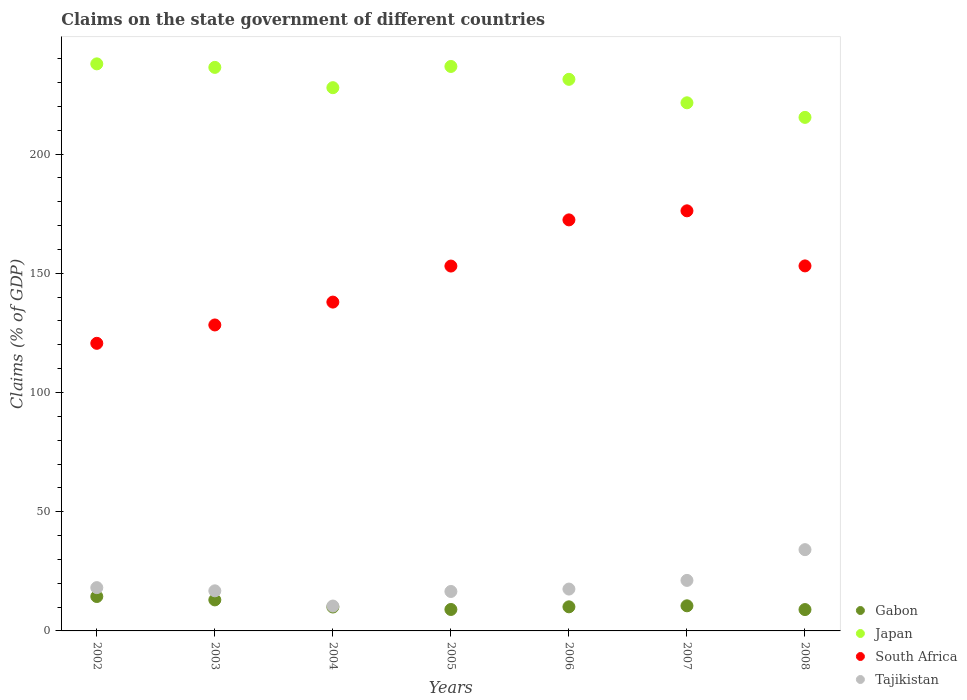How many different coloured dotlines are there?
Make the answer very short. 4. What is the percentage of GDP claimed on the state government in Japan in 2005?
Offer a very short reply. 236.77. Across all years, what is the maximum percentage of GDP claimed on the state government in Gabon?
Give a very brief answer. 14.43. Across all years, what is the minimum percentage of GDP claimed on the state government in Gabon?
Offer a terse response. 8.96. What is the total percentage of GDP claimed on the state government in Tajikistan in the graph?
Offer a terse response. 134.79. What is the difference between the percentage of GDP claimed on the state government in Tajikistan in 2003 and that in 2007?
Your response must be concise. -4.37. What is the difference between the percentage of GDP claimed on the state government in Japan in 2002 and the percentage of GDP claimed on the state government in Tajikistan in 2007?
Your answer should be very brief. 216.66. What is the average percentage of GDP claimed on the state government in Gabon per year?
Your answer should be very brief. 10.87. In the year 2008, what is the difference between the percentage of GDP claimed on the state government in Japan and percentage of GDP claimed on the state government in Gabon?
Keep it short and to the point. 206.45. In how many years, is the percentage of GDP claimed on the state government in Japan greater than 200 %?
Provide a succinct answer. 7. What is the ratio of the percentage of GDP claimed on the state government in Tajikistan in 2003 to that in 2006?
Your response must be concise. 0.96. Is the percentage of GDP claimed on the state government in Tajikistan in 2005 less than that in 2008?
Offer a terse response. Yes. Is the difference between the percentage of GDP claimed on the state government in Japan in 2004 and 2007 greater than the difference between the percentage of GDP claimed on the state government in Gabon in 2004 and 2007?
Make the answer very short. Yes. What is the difference between the highest and the second highest percentage of GDP claimed on the state government in Tajikistan?
Provide a short and direct response. 12.9. What is the difference between the highest and the lowest percentage of GDP claimed on the state government in Japan?
Keep it short and to the point. 22.45. In how many years, is the percentage of GDP claimed on the state government in Tajikistan greater than the average percentage of GDP claimed on the state government in Tajikistan taken over all years?
Offer a terse response. 2. Is the sum of the percentage of GDP claimed on the state government in Tajikistan in 2004 and 2007 greater than the maximum percentage of GDP claimed on the state government in Gabon across all years?
Your answer should be very brief. Yes. What is the difference between two consecutive major ticks on the Y-axis?
Your response must be concise. 50. Are the values on the major ticks of Y-axis written in scientific E-notation?
Your response must be concise. No. Does the graph contain grids?
Make the answer very short. No. Where does the legend appear in the graph?
Your response must be concise. Bottom right. How are the legend labels stacked?
Provide a succinct answer. Vertical. What is the title of the graph?
Make the answer very short. Claims on the state government of different countries. Does "Europe(all income levels)" appear as one of the legend labels in the graph?
Ensure brevity in your answer.  No. What is the label or title of the X-axis?
Your answer should be compact. Years. What is the label or title of the Y-axis?
Offer a very short reply. Claims (% of GDP). What is the Claims (% of GDP) in Gabon in 2002?
Provide a short and direct response. 14.43. What is the Claims (% of GDP) in Japan in 2002?
Provide a short and direct response. 237.85. What is the Claims (% of GDP) of South Africa in 2002?
Provide a short and direct response. 120.63. What is the Claims (% of GDP) in Tajikistan in 2002?
Make the answer very short. 18.16. What is the Claims (% of GDP) of Gabon in 2003?
Ensure brevity in your answer.  13.01. What is the Claims (% of GDP) of Japan in 2003?
Provide a succinct answer. 236.37. What is the Claims (% of GDP) in South Africa in 2003?
Keep it short and to the point. 128.34. What is the Claims (% of GDP) of Tajikistan in 2003?
Offer a very short reply. 16.82. What is the Claims (% of GDP) in Gabon in 2004?
Offer a terse response. 10.03. What is the Claims (% of GDP) in Japan in 2004?
Provide a short and direct response. 227.86. What is the Claims (% of GDP) of South Africa in 2004?
Your answer should be very brief. 137.93. What is the Claims (% of GDP) of Tajikistan in 2004?
Give a very brief answer. 10.44. What is the Claims (% of GDP) of Gabon in 2005?
Your answer should be compact. 9. What is the Claims (% of GDP) of Japan in 2005?
Make the answer very short. 236.77. What is the Claims (% of GDP) of South Africa in 2005?
Make the answer very short. 153.04. What is the Claims (% of GDP) of Tajikistan in 2005?
Provide a succinct answer. 16.54. What is the Claims (% of GDP) of Gabon in 2006?
Offer a terse response. 10.11. What is the Claims (% of GDP) of Japan in 2006?
Provide a succinct answer. 231.36. What is the Claims (% of GDP) of South Africa in 2006?
Keep it short and to the point. 172.41. What is the Claims (% of GDP) in Tajikistan in 2006?
Give a very brief answer. 17.56. What is the Claims (% of GDP) in Gabon in 2007?
Your response must be concise. 10.53. What is the Claims (% of GDP) of Japan in 2007?
Provide a succinct answer. 221.52. What is the Claims (% of GDP) in South Africa in 2007?
Provide a short and direct response. 176.21. What is the Claims (% of GDP) in Tajikistan in 2007?
Ensure brevity in your answer.  21.19. What is the Claims (% of GDP) in Gabon in 2008?
Offer a terse response. 8.96. What is the Claims (% of GDP) of Japan in 2008?
Provide a short and direct response. 215.41. What is the Claims (% of GDP) of South Africa in 2008?
Your answer should be compact. 153.11. What is the Claims (% of GDP) of Tajikistan in 2008?
Your answer should be compact. 34.09. Across all years, what is the maximum Claims (% of GDP) of Gabon?
Your response must be concise. 14.43. Across all years, what is the maximum Claims (% of GDP) of Japan?
Keep it short and to the point. 237.85. Across all years, what is the maximum Claims (% of GDP) of South Africa?
Offer a very short reply. 176.21. Across all years, what is the maximum Claims (% of GDP) of Tajikistan?
Your answer should be compact. 34.09. Across all years, what is the minimum Claims (% of GDP) in Gabon?
Ensure brevity in your answer.  8.96. Across all years, what is the minimum Claims (% of GDP) of Japan?
Provide a short and direct response. 215.41. Across all years, what is the minimum Claims (% of GDP) in South Africa?
Offer a very short reply. 120.63. Across all years, what is the minimum Claims (% of GDP) in Tajikistan?
Ensure brevity in your answer.  10.44. What is the total Claims (% of GDP) of Gabon in the graph?
Your answer should be compact. 76.07. What is the total Claims (% of GDP) of Japan in the graph?
Provide a short and direct response. 1607.15. What is the total Claims (% of GDP) in South Africa in the graph?
Make the answer very short. 1041.67. What is the total Claims (% of GDP) in Tajikistan in the graph?
Your answer should be compact. 134.79. What is the difference between the Claims (% of GDP) in Gabon in 2002 and that in 2003?
Offer a terse response. 1.42. What is the difference between the Claims (% of GDP) in Japan in 2002 and that in 2003?
Keep it short and to the point. 1.48. What is the difference between the Claims (% of GDP) in South Africa in 2002 and that in 2003?
Your response must be concise. -7.7. What is the difference between the Claims (% of GDP) in Tajikistan in 2002 and that in 2003?
Your answer should be very brief. 1.34. What is the difference between the Claims (% of GDP) in Gabon in 2002 and that in 2004?
Ensure brevity in your answer.  4.4. What is the difference between the Claims (% of GDP) in Japan in 2002 and that in 2004?
Give a very brief answer. 9.99. What is the difference between the Claims (% of GDP) of South Africa in 2002 and that in 2004?
Keep it short and to the point. -17.29. What is the difference between the Claims (% of GDP) in Tajikistan in 2002 and that in 2004?
Offer a very short reply. 7.72. What is the difference between the Claims (% of GDP) of Gabon in 2002 and that in 2005?
Ensure brevity in your answer.  5.44. What is the difference between the Claims (% of GDP) of Japan in 2002 and that in 2005?
Give a very brief answer. 1.09. What is the difference between the Claims (% of GDP) of South Africa in 2002 and that in 2005?
Ensure brevity in your answer.  -32.41. What is the difference between the Claims (% of GDP) in Tajikistan in 2002 and that in 2005?
Your answer should be very brief. 1.62. What is the difference between the Claims (% of GDP) of Gabon in 2002 and that in 2006?
Your response must be concise. 4.33. What is the difference between the Claims (% of GDP) in Japan in 2002 and that in 2006?
Offer a very short reply. 6.49. What is the difference between the Claims (% of GDP) in South Africa in 2002 and that in 2006?
Offer a very short reply. -51.77. What is the difference between the Claims (% of GDP) of Tajikistan in 2002 and that in 2006?
Provide a short and direct response. 0.6. What is the difference between the Claims (% of GDP) in Gabon in 2002 and that in 2007?
Give a very brief answer. 3.9. What is the difference between the Claims (% of GDP) in Japan in 2002 and that in 2007?
Keep it short and to the point. 16.33. What is the difference between the Claims (% of GDP) of South Africa in 2002 and that in 2007?
Ensure brevity in your answer.  -55.57. What is the difference between the Claims (% of GDP) of Tajikistan in 2002 and that in 2007?
Provide a succinct answer. -3.03. What is the difference between the Claims (% of GDP) in Gabon in 2002 and that in 2008?
Your answer should be compact. 5.48. What is the difference between the Claims (% of GDP) in Japan in 2002 and that in 2008?
Your answer should be compact. 22.45. What is the difference between the Claims (% of GDP) of South Africa in 2002 and that in 2008?
Provide a succinct answer. -32.47. What is the difference between the Claims (% of GDP) of Tajikistan in 2002 and that in 2008?
Make the answer very short. -15.93. What is the difference between the Claims (% of GDP) of Gabon in 2003 and that in 2004?
Provide a succinct answer. 2.98. What is the difference between the Claims (% of GDP) of Japan in 2003 and that in 2004?
Your answer should be very brief. 8.51. What is the difference between the Claims (% of GDP) in South Africa in 2003 and that in 2004?
Keep it short and to the point. -9.59. What is the difference between the Claims (% of GDP) in Tajikistan in 2003 and that in 2004?
Your answer should be very brief. 6.38. What is the difference between the Claims (% of GDP) in Gabon in 2003 and that in 2005?
Provide a short and direct response. 4.01. What is the difference between the Claims (% of GDP) of Japan in 2003 and that in 2005?
Ensure brevity in your answer.  -0.39. What is the difference between the Claims (% of GDP) in South Africa in 2003 and that in 2005?
Offer a very short reply. -24.7. What is the difference between the Claims (% of GDP) in Tajikistan in 2003 and that in 2005?
Offer a terse response. 0.27. What is the difference between the Claims (% of GDP) in Gabon in 2003 and that in 2006?
Keep it short and to the point. 2.9. What is the difference between the Claims (% of GDP) in Japan in 2003 and that in 2006?
Keep it short and to the point. 5.01. What is the difference between the Claims (% of GDP) in South Africa in 2003 and that in 2006?
Provide a short and direct response. -44.07. What is the difference between the Claims (% of GDP) in Tajikistan in 2003 and that in 2006?
Keep it short and to the point. -0.74. What is the difference between the Claims (% of GDP) in Gabon in 2003 and that in 2007?
Offer a very short reply. 2.48. What is the difference between the Claims (% of GDP) of Japan in 2003 and that in 2007?
Your answer should be very brief. 14.85. What is the difference between the Claims (% of GDP) of South Africa in 2003 and that in 2007?
Offer a very short reply. -47.87. What is the difference between the Claims (% of GDP) of Tajikistan in 2003 and that in 2007?
Your response must be concise. -4.37. What is the difference between the Claims (% of GDP) in Gabon in 2003 and that in 2008?
Ensure brevity in your answer.  4.05. What is the difference between the Claims (% of GDP) of Japan in 2003 and that in 2008?
Make the answer very short. 20.97. What is the difference between the Claims (% of GDP) of South Africa in 2003 and that in 2008?
Ensure brevity in your answer.  -24.77. What is the difference between the Claims (% of GDP) in Tajikistan in 2003 and that in 2008?
Give a very brief answer. -17.27. What is the difference between the Claims (% of GDP) of Gabon in 2004 and that in 2005?
Provide a short and direct response. 1.04. What is the difference between the Claims (% of GDP) in Japan in 2004 and that in 2005?
Your answer should be very brief. -8.9. What is the difference between the Claims (% of GDP) of South Africa in 2004 and that in 2005?
Offer a very short reply. -15.12. What is the difference between the Claims (% of GDP) of Tajikistan in 2004 and that in 2005?
Your response must be concise. -6.11. What is the difference between the Claims (% of GDP) of Gabon in 2004 and that in 2006?
Provide a short and direct response. -0.07. What is the difference between the Claims (% of GDP) in Japan in 2004 and that in 2006?
Provide a succinct answer. -3.5. What is the difference between the Claims (% of GDP) in South Africa in 2004 and that in 2006?
Provide a short and direct response. -34.48. What is the difference between the Claims (% of GDP) of Tajikistan in 2004 and that in 2006?
Offer a very short reply. -7.12. What is the difference between the Claims (% of GDP) of Gabon in 2004 and that in 2007?
Your answer should be very brief. -0.5. What is the difference between the Claims (% of GDP) in Japan in 2004 and that in 2007?
Give a very brief answer. 6.34. What is the difference between the Claims (% of GDP) in South Africa in 2004 and that in 2007?
Your response must be concise. -38.28. What is the difference between the Claims (% of GDP) in Tajikistan in 2004 and that in 2007?
Offer a terse response. -10.75. What is the difference between the Claims (% of GDP) in Gabon in 2004 and that in 2008?
Give a very brief answer. 1.08. What is the difference between the Claims (% of GDP) in Japan in 2004 and that in 2008?
Make the answer very short. 12.46. What is the difference between the Claims (% of GDP) of South Africa in 2004 and that in 2008?
Offer a very short reply. -15.18. What is the difference between the Claims (% of GDP) of Tajikistan in 2004 and that in 2008?
Your answer should be compact. -23.65. What is the difference between the Claims (% of GDP) of Gabon in 2005 and that in 2006?
Your answer should be compact. -1.11. What is the difference between the Claims (% of GDP) in Japan in 2005 and that in 2006?
Ensure brevity in your answer.  5.4. What is the difference between the Claims (% of GDP) in South Africa in 2005 and that in 2006?
Ensure brevity in your answer.  -19.37. What is the difference between the Claims (% of GDP) in Tajikistan in 2005 and that in 2006?
Offer a very short reply. -1.01. What is the difference between the Claims (% of GDP) in Gabon in 2005 and that in 2007?
Your answer should be compact. -1.54. What is the difference between the Claims (% of GDP) of Japan in 2005 and that in 2007?
Your response must be concise. 15.24. What is the difference between the Claims (% of GDP) of South Africa in 2005 and that in 2007?
Offer a terse response. -23.17. What is the difference between the Claims (% of GDP) in Tajikistan in 2005 and that in 2007?
Your answer should be very brief. -4.65. What is the difference between the Claims (% of GDP) in Gabon in 2005 and that in 2008?
Provide a succinct answer. 0.04. What is the difference between the Claims (% of GDP) in Japan in 2005 and that in 2008?
Keep it short and to the point. 21.36. What is the difference between the Claims (% of GDP) in South Africa in 2005 and that in 2008?
Give a very brief answer. -0.06. What is the difference between the Claims (% of GDP) in Tajikistan in 2005 and that in 2008?
Provide a short and direct response. -17.55. What is the difference between the Claims (% of GDP) of Gabon in 2006 and that in 2007?
Give a very brief answer. -0.43. What is the difference between the Claims (% of GDP) in Japan in 2006 and that in 2007?
Your response must be concise. 9.84. What is the difference between the Claims (% of GDP) of South Africa in 2006 and that in 2007?
Ensure brevity in your answer.  -3.8. What is the difference between the Claims (% of GDP) in Tajikistan in 2006 and that in 2007?
Ensure brevity in your answer.  -3.63. What is the difference between the Claims (% of GDP) in Gabon in 2006 and that in 2008?
Your answer should be compact. 1.15. What is the difference between the Claims (% of GDP) in Japan in 2006 and that in 2008?
Provide a short and direct response. 15.96. What is the difference between the Claims (% of GDP) in South Africa in 2006 and that in 2008?
Provide a short and direct response. 19.3. What is the difference between the Claims (% of GDP) of Tajikistan in 2006 and that in 2008?
Ensure brevity in your answer.  -16.53. What is the difference between the Claims (% of GDP) in Gabon in 2007 and that in 2008?
Offer a terse response. 1.58. What is the difference between the Claims (% of GDP) of Japan in 2007 and that in 2008?
Your answer should be compact. 6.12. What is the difference between the Claims (% of GDP) in South Africa in 2007 and that in 2008?
Your answer should be very brief. 23.1. What is the difference between the Claims (% of GDP) in Tajikistan in 2007 and that in 2008?
Offer a terse response. -12.9. What is the difference between the Claims (% of GDP) of Gabon in 2002 and the Claims (% of GDP) of Japan in 2003?
Ensure brevity in your answer.  -221.94. What is the difference between the Claims (% of GDP) in Gabon in 2002 and the Claims (% of GDP) in South Africa in 2003?
Ensure brevity in your answer.  -113.9. What is the difference between the Claims (% of GDP) of Gabon in 2002 and the Claims (% of GDP) of Tajikistan in 2003?
Ensure brevity in your answer.  -2.38. What is the difference between the Claims (% of GDP) of Japan in 2002 and the Claims (% of GDP) of South Africa in 2003?
Provide a short and direct response. 109.52. What is the difference between the Claims (% of GDP) in Japan in 2002 and the Claims (% of GDP) in Tajikistan in 2003?
Make the answer very short. 221.04. What is the difference between the Claims (% of GDP) of South Africa in 2002 and the Claims (% of GDP) of Tajikistan in 2003?
Offer a terse response. 103.82. What is the difference between the Claims (% of GDP) of Gabon in 2002 and the Claims (% of GDP) of Japan in 2004?
Your answer should be compact. -213.43. What is the difference between the Claims (% of GDP) of Gabon in 2002 and the Claims (% of GDP) of South Africa in 2004?
Offer a very short reply. -123.49. What is the difference between the Claims (% of GDP) of Gabon in 2002 and the Claims (% of GDP) of Tajikistan in 2004?
Offer a very short reply. 4. What is the difference between the Claims (% of GDP) of Japan in 2002 and the Claims (% of GDP) of South Africa in 2004?
Give a very brief answer. 99.93. What is the difference between the Claims (% of GDP) of Japan in 2002 and the Claims (% of GDP) of Tajikistan in 2004?
Your answer should be very brief. 227.42. What is the difference between the Claims (% of GDP) in South Africa in 2002 and the Claims (% of GDP) in Tajikistan in 2004?
Your answer should be very brief. 110.2. What is the difference between the Claims (% of GDP) in Gabon in 2002 and the Claims (% of GDP) in Japan in 2005?
Give a very brief answer. -222.33. What is the difference between the Claims (% of GDP) of Gabon in 2002 and the Claims (% of GDP) of South Africa in 2005?
Ensure brevity in your answer.  -138.61. What is the difference between the Claims (% of GDP) of Gabon in 2002 and the Claims (% of GDP) of Tajikistan in 2005?
Keep it short and to the point. -2.11. What is the difference between the Claims (% of GDP) of Japan in 2002 and the Claims (% of GDP) of South Africa in 2005?
Offer a very short reply. 84.81. What is the difference between the Claims (% of GDP) of Japan in 2002 and the Claims (% of GDP) of Tajikistan in 2005?
Offer a very short reply. 221.31. What is the difference between the Claims (% of GDP) in South Africa in 2002 and the Claims (% of GDP) in Tajikistan in 2005?
Give a very brief answer. 104.09. What is the difference between the Claims (% of GDP) in Gabon in 2002 and the Claims (% of GDP) in Japan in 2006?
Make the answer very short. -216.93. What is the difference between the Claims (% of GDP) of Gabon in 2002 and the Claims (% of GDP) of South Africa in 2006?
Your response must be concise. -157.97. What is the difference between the Claims (% of GDP) in Gabon in 2002 and the Claims (% of GDP) in Tajikistan in 2006?
Provide a succinct answer. -3.12. What is the difference between the Claims (% of GDP) in Japan in 2002 and the Claims (% of GDP) in South Africa in 2006?
Give a very brief answer. 65.45. What is the difference between the Claims (% of GDP) in Japan in 2002 and the Claims (% of GDP) in Tajikistan in 2006?
Give a very brief answer. 220.3. What is the difference between the Claims (% of GDP) in South Africa in 2002 and the Claims (% of GDP) in Tajikistan in 2006?
Make the answer very short. 103.08. What is the difference between the Claims (% of GDP) in Gabon in 2002 and the Claims (% of GDP) in Japan in 2007?
Give a very brief answer. -207.09. What is the difference between the Claims (% of GDP) in Gabon in 2002 and the Claims (% of GDP) in South Africa in 2007?
Your answer should be compact. -161.77. What is the difference between the Claims (% of GDP) of Gabon in 2002 and the Claims (% of GDP) of Tajikistan in 2007?
Offer a very short reply. -6.76. What is the difference between the Claims (% of GDP) in Japan in 2002 and the Claims (% of GDP) in South Africa in 2007?
Your response must be concise. 61.65. What is the difference between the Claims (% of GDP) in Japan in 2002 and the Claims (% of GDP) in Tajikistan in 2007?
Make the answer very short. 216.66. What is the difference between the Claims (% of GDP) in South Africa in 2002 and the Claims (% of GDP) in Tajikistan in 2007?
Offer a very short reply. 99.44. What is the difference between the Claims (% of GDP) in Gabon in 2002 and the Claims (% of GDP) in Japan in 2008?
Offer a terse response. -200.97. What is the difference between the Claims (% of GDP) in Gabon in 2002 and the Claims (% of GDP) in South Africa in 2008?
Give a very brief answer. -138.67. What is the difference between the Claims (% of GDP) in Gabon in 2002 and the Claims (% of GDP) in Tajikistan in 2008?
Offer a terse response. -19.66. What is the difference between the Claims (% of GDP) in Japan in 2002 and the Claims (% of GDP) in South Africa in 2008?
Make the answer very short. 84.75. What is the difference between the Claims (% of GDP) in Japan in 2002 and the Claims (% of GDP) in Tajikistan in 2008?
Offer a terse response. 203.76. What is the difference between the Claims (% of GDP) in South Africa in 2002 and the Claims (% of GDP) in Tajikistan in 2008?
Your response must be concise. 86.54. What is the difference between the Claims (% of GDP) of Gabon in 2003 and the Claims (% of GDP) of Japan in 2004?
Provide a short and direct response. -214.85. What is the difference between the Claims (% of GDP) in Gabon in 2003 and the Claims (% of GDP) in South Africa in 2004?
Keep it short and to the point. -124.92. What is the difference between the Claims (% of GDP) of Gabon in 2003 and the Claims (% of GDP) of Tajikistan in 2004?
Your answer should be compact. 2.58. What is the difference between the Claims (% of GDP) of Japan in 2003 and the Claims (% of GDP) of South Africa in 2004?
Offer a terse response. 98.45. What is the difference between the Claims (% of GDP) in Japan in 2003 and the Claims (% of GDP) in Tajikistan in 2004?
Offer a terse response. 225.94. What is the difference between the Claims (% of GDP) in South Africa in 2003 and the Claims (% of GDP) in Tajikistan in 2004?
Give a very brief answer. 117.9. What is the difference between the Claims (% of GDP) of Gabon in 2003 and the Claims (% of GDP) of Japan in 2005?
Provide a succinct answer. -223.76. What is the difference between the Claims (% of GDP) of Gabon in 2003 and the Claims (% of GDP) of South Africa in 2005?
Offer a very short reply. -140.03. What is the difference between the Claims (% of GDP) in Gabon in 2003 and the Claims (% of GDP) in Tajikistan in 2005?
Provide a short and direct response. -3.53. What is the difference between the Claims (% of GDP) of Japan in 2003 and the Claims (% of GDP) of South Africa in 2005?
Give a very brief answer. 83.33. What is the difference between the Claims (% of GDP) of Japan in 2003 and the Claims (% of GDP) of Tajikistan in 2005?
Offer a very short reply. 219.83. What is the difference between the Claims (% of GDP) of South Africa in 2003 and the Claims (% of GDP) of Tajikistan in 2005?
Provide a succinct answer. 111.79. What is the difference between the Claims (% of GDP) of Gabon in 2003 and the Claims (% of GDP) of Japan in 2006?
Provide a short and direct response. -218.35. What is the difference between the Claims (% of GDP) in Gabon in 2003 and the Claims (% of GDP) in South Africa in 2006?
Make the answer very short. -159.4. What is the difference between the Claims (% of GDP) of Gabon in 2003 and the Claims (% of GDP) of Tajikistan in 2006?
Offer a terse response. -4.54. What is the difference between the Claims (% of GDP) of Japan in 2003 and the Claims (% of GDP) of South Africa in 2006?
Provide a short and direct response. 63.97. What is the difference between the Claims (% of GDP) of Japan in 2003 and the Claims (% of GDP) of Tajikistan in 2006?
Your answer should be compact. 218.82. What is the difference between the Claims (% of GDP) of South Africa in 2003 and the Claims (% of GDP) of Tajikistan in 2006?
Give a very brief answer. 110.78. What is the difference between the Claims (% of GDP) in Gabon in 2003 and the Claims (% of GDP) in Japan in 2007?
Your answer should be compact. -208.51. What is the difference between the Claims (% of GDP) of Gabon in 2003 and the Claims (% of GDP) of South Africa in 2007?
Ensure brevity in your answer.  -163.2. What is the difference between the Claims (% of GDP) of Gabon in 2003 and the Claims (% of GDP) of Tajikistan in 2007?
Offer a terse response. -8.18. What is the difference between the Claims (% of GDP) of Japan in 2003 and the Claims (% of GDP) of South Africa in 2007?
Your response must be concise. 60.17. What is the difference between the Claims (% of GDP) in Japan in 2003 and the Claims (% of GDP) in Tajikistan in 2007?
Provide a succinct answer. 215.18. What is the difference between the Claims (% of GDP) in South Africa in 2003 and the Claims (% of GDP) in Tajikistan in 2007?
Ensure brevity in your answer.  107.15. What is the difference between the Claims (% of GDP) in Gabon in 2003 and the Claims (% of GDP) in Japan in 2008?
Provide a succinct answer. -202.4. What is the difference between the Claims (% of GDP) in Gabon in 2003 and the Claims (% of GDP) in South Africa in 2008?
Provide a short and direct response. -140.1. What is the difference between the Claims (% of GDP) of Gabon in 2003 and the Claims (% of GDP) of Tajikistan in 2008?
Your response must be concise. -21.08. What is the difference between the Claims (% of GDP) in Japan in 2003 and the Claims (% of GDP) in South Africa in 2008?
Make the answer very short. 83.27. What is the difference between the Claims (% of GDP) of Japan in 2003 and the Claims (% of GDP) of Tajikistan in 2008?
Your answer should be compact. 202.28. What is the difference between the Claims (% of GDP) of South Africa in 2003 and the Claims (% of GDP) of Tajikistan in 2008?
Make the answer very short. 94.25. What is the difference between the Claims (% of GDP) in Gabon in 2004 and the Claims (% of GDP) in Japan in 2005?
Provide a succinct answer. -226.73. What is the difference between the Claims (% of GDP) of Gabon in 2004 and the Claims (% of GDP) of South Africa in 2005?
Provide a short and direct response. -143.01. What is the difference between the Claims (% of GDP) of Gabon in 2004 and the Claims (% of GDP) of Tajikistan in 2005?
Ensure brevity in your answer.  -6.51. What is the difference between the Claims (% of GDP) in Japan in 2004 and the Claims (% of GDP) in South Africa in 2005?
Ensure brevity in your answer.  74.82. What is the difference between the Claims (% of GDP) of Japan in 2004 and the Claims (% of GDP) of Tajikistan in 2005?
Make the answer very short. 211.32. What is the difference between the Claims (% of GDP) in South Africa in 2004 and the Claims (% of GDP) in Tajikistan in 2005?
Offer a very short reply. 121.38. What is the difference between the Claims (% of GDP) in Gabon in 2004 and the Claims (% of GDP) in Japan in 2006?
Offer a terse response. -221.33. What is the difference between the Claims (% of GDP) in Gabon in 2004 and the Claims (% of GDP) in South Africa in 2006?
Your answer should be compact. -162.38. What is the difference between the Claims (% of GDP) in Gabon in 2004 and the Claims (% of GDP) in Tajikistan in 2006?
Provide a succinct answer. -7.52. What is the difference between the Claims (% of GDP) in Japan in 2004 and the Claims (% of GDP) in South Africa in 2006?
Provide a short and direct response. 55.45. What is the difference between the Claims (% of GDP) in Japan in 2004 and the Claims (% of GDP) in Tajikistan in 2006?
Provide a succinct answer. 210.31. What is the difference between the Claims (% of GDP) in South Africa in 2004 and the Claims (% of GDP) in Tajikistan in 2006?
Offer a terse response. 120.37. What is the difference between the Claims (% of GDP) of Gabon in 2004 and the Claims (% of GDP) of Japan in 2007?
Offer a very short reply. -211.49. What is the difference between the Claims (% of GDP) of Gabon in 2004 and the Claims (% of GDP) of South Africa in 2007?
Make the answer very short. -166.18. What is the difference between the Claims (% of GDP) of Gabon in 2004 and the Claims (% of GDP) of Tajikistan in 2007?
Make the answer very short. -11.16. What is the difference between the Claims (% of GDP) of Japan in 2004 and the Claims (% of GDP) of South Africa in 2007?
Your answer should be compact. 51.65. What is the difference between the Claims (% of GDP) in Japan in 2004 and the Claims (% of GDP) in Tajikistan in 2007?
Provide a succinct answer. 206.67. What is the difference between the Claims (% of GDP) of South Africa in 2004 and the Claims (% of GDP) of Tajikistan in 2007?
Ensure brevity in your answer.  116.74. What is the difference between the Claims (% of GDP) of Gabon in 2004 and the Claims (% of GDP) of Japan in 2008?
Provide a succinct answer. -205.37. What is the difference between the Claims (% of GDP) in Gabon in 2004 and the Claims (% of GDP) in South Africa in 2008?
Your answer should be very brief. -143.07. What is the difference between the Claims (% of GDP) in Gabon in 2004 and the Claims (% of GDP) in Tajikistan in 2008?
Offer a very short reply. -24.06. What is the difference between the Claims (% of GDP) of Japan in 2004 and the Claims (% of GDP) of South Africa in 2008?
Give a very brief answer. 74.76. What is the difference between the Claims (% of GDP) of Japan in 2004 and the Claims (% of GDP) of Tajikistan in 2008?
Give a very brief answer. 193.77. What is the difference between the Claims (% of GDP) of South Africa in 2004 and the Claims (% of GDP) of Tajikistan in 2008?
Offer a terse response. 103.84. What is the difference between the Claims (% of GDP) in Gabon in 2005 and the Claims (% of GDP) in Japan in 2006?
Your answer should be compact. -222.37. What is the difference between the Claims (% of GDP) of Gabon in 2005 and the Claims (% of GDP) of South Africa in 2006?
Make the answer very short. -163.41. What is the difference between the Claims (% of GDP) in Gabon in 2005 and the Claims (% of GDP) in Tajikistan in 2006?
Offer a terse response. -8.56. What is the difference between the Claims (% of GDP) in Japan in 2005 and the Claims (% of GDP) in South Africa in 2006?
Your answer should be very brief. 64.36. What is the difference between the Claims (% of GDP) in Japan in 2005 and the Claims (% of GDP) in Tajikistan in 2006?
Ensure brevity in your answer.  219.21. What is the difference between the Claims (% of GDP) in South Africa in 2005 and the Claims (% of GDP) in Tajikistan in 2006?
Make the answer very short. 135.49. What is the difference between the Claims (% of GDP) of Gabon in 2005 and the Claims (% of GDP) of Japan in 2007?
Make the answer very short. -212.53. What is the difference between the Claims (% of GDP) of Gabon in 2005 and the Claims (% of GDP) of South Africa in 2007?
Provide a succinct answer. -167.21. What is the difference between the Claims (% of GDP) of Gabon in 2005 and the Claims (% of GDP) of Tajikistan in 2007?
Offer a very short reply. -12.19. What is the difference between the Claims (% of GDP) of Japan in 2005 and the Claims (% of GDP) of South Africa in 2007?
Make the answer very short. 60.56. What is the difference between the Claims (% of GDP) of Japan in 2005 and the Claims (% of GDP) of Tajikistan in 2007?
Give a very brief answer. 215.58. What is the difference between the Claims (% of GDP) in South Africa in 2005 and the Claims (% of GDP) in Tajikistan in 2007?
Provide a succinct answer. 131.85. What is the difference between the Claims (% of GDP) in Gabon in 2005 and the Claims (% of GDP) in Japan in 2008?
Give a very brief answer. -206.41. What is the difference between the Claims (% of GDP) in Gabon in 2005 and the Claims (% of GDP) in South Africa in 2008?
Offer a terse response. -144.11. What is the difference between the Claims (% of GDP) of Gabon in 2005 and the Claims (% of GDP) of Tajikistan in 2008?
Give a very brief answer. -25.09. What is the difference between the Claims (% of GDP) of Japan in 2005 and the Claims (% of GDP) of South Africa in 2008?
Your answer should be very brief. 83.66. What is the difference between the Claims (% of GDP) in Japan in 2005 and the Claims (% of GDP) in Tajikistan in 2008?
Ensure brevity in your answer.  202.68. What is the difference between the Claims (% of GDP) in South Africa in 2005 and the Claims (% of GDP) in Tajikistan in 2008?
Provide a succinct answer. 118.95. What is the difference between the Claims (% of GDP) in Gabon in 2006 and the Claims (% of GDP) in Japan in 2007?
Provide a short and direct response. -211.42. What is the difference between the Claims (% of GDP) in Gabon in 2006 and the Claims (% of GDP) in South Africa in 2007?
Offer a very short reply. -166.1. What is the difference between the Claims (% of GDP) of Gabon in 2006 and the Claims (% of GDP) of Tajikistan in 2007?
Provide a short and direct response. -11.08. What is the difference between the Claims (% of GDP) in Japan in 2006 and the Claims (% of GDP) in South Africa in 2007?
Provide a short and direct response. 55.16. What is the difference between the Claims (% of GDP) of Japan in 2006 and the Claims (% of GDP) of Tajikistan in 2007?
Keep it short and to the point. 210.17. What is the difference between the Claims (% of GDP) of South Africa in 2006 and the Claims (% of GDP) of Tajikistan in 2007?
Make the answer very short. 151.22. What is the difference between the Claims (% of GDP) in Gabon in 2006 and the Claims (% of GDP) in Japan in 2008?
Provide a short and direct response. -205.3. What is the difference between the Claims (% of GDP) of Gabon in 2006 and the Claims (% of GDP) of South Africa in 2008?
Your response must be concise. -143. What is the difference between the Claims (% of GDP) of Gabon in 2006 and the Claims (% of GDP) of Tajikistan in 2008?
Ensure brevity in your answer.  -23.98. What is the difference between the Claims (% of GDP) in Japan in 2006 and the Claims (% of GDP) in South Africa in 2008?
Provide a succinct answer. 78.26. What is the difference between the Claims (% of GDP) of Japan in 2006 and the Claims (% of GDP) of Tajikistan in 2008?
Give a very brief answer. 197.27. What is the difference between the Claims (% of GDP) in South Africa in 2006 and the Claims (% of GDP) in Tajikistan in 2008?
Make the answer very short. 138.32. What is the difference between the Claims (% of GDP) of Gabon in 2007 and the Claims (% of GDP) of Japan in 2008?
Your answer should be compact. -204.87. What is the difference between the Claims (% of GDP) of Gabon in 2007 and the Claims (% of GDP) of South Africa in 2008?
Ensure brevity in your answer.  -142.57. What is the difference between the Claims (% of GDP) in Gabon in 2007 and the Claims (% of GDP) in Tajikistan in 2008?
Provide a succinct answer. -23.56. What is the difference between the Claims (% of GDP) of Japan in 2007 and the Claims (% of GDP) of South Africa in 2008?
Ensure brevity in your answer.  68.42. What is the difference between the Claims (% of GDP) of Japan in 2007 and the Claims (% of GDP) of Tajikistan in 2008?
Keep it short and to the point. 187.43. What is the difference between the Claims (% of GDP) of South Africa in 2007 and the Claims (% of GDP) of Tajikistan in 2008?
Give a very brief answer. 142.12. What is the average Claims (% of GDP) of Gabon per year?
Provide a short and direct response. 10.87. What is the average Claims (% of GDP) in Japan per year?
Your answer should be very brief. 229.59. What is the average Claims (% of GDP) of South Africa per year?
Your answer should be very brief. 148.81. What is the average Claims (% of GDP) in Tajikistan per year?
Ensure brevity in your answer.  19.26. In the year 2002, what is the difference between the Claims (% of GDP) in Gabon and Claims (% of GDP) in Japan?
Provide a succinct answer. -223.42. In the year 2002, what is the difference between the Claims (% of GDP) of Gabon and Claims (% of GDP) of South Africa?
Your answer should be very brief. -106.2. In the year 2002, what is the difference between the Claims (% of GDP) in Gabon and Claims (% of GDP) in Tajikistan?
Offer a very short reply. -3.73. In the year 2002, what is the difference between the Claims (% of GDP) in Japan and Claims (% of GDP) in South Africa?
Provide a succinct answer. 117.22. In the year 2002, what is the difference between the Claims (% of GDP) of Japan and Claims (% of GDP) of Tajikistan?
Make the answer very short. 219.69. In the year 2002, what is the difference between the Claims (% of GDP) in South Africa and Claims (% of GDP) in Tajikistan?
Your response must be concise. 102.47. In the year 2003, what is the difference between the Claims (% of GDP) in Gabon and Claims (% of GDP) in Japan?
Make the answer very short. -223.36. In the year 2003, what is the difference between the Claims (% of GDP) of Gabon and Claims (% of GDP) of South Africa?
Make the answer very short. -115.33. In the year 2003, what is the difference between the Claims (% of GDP) of Gabon and Claims (% of GDP) of Tajikistan?
Provide a succinct answer. -3.81. In the year 2003, what is the difference between the Claims (% of GDP) of Japan and Claims (% of GDP) of South Africa?
Provide a succinct answer. 108.04. In the year 2003, what is the difference between the Claims (% of GDP) in Japan and Claims (% of GDP) in Tajikistan?
Offer a terse response. 219.56. In the year 2003, what is the difference between the Claims (% of GDP) in South Africa and Claims (% of GDP) in Tajikistan?
Provide a succinct answer. 111.52. In the year 2004, what is the difference between the Claims (% of GDP) of Gabon and Claims (% of GDP) of Japan?
Keep it short and to the point. -217.83. In the year 2004, what is the difference between the Claims (% of GDP) of Gabon and Claims (% of GDP) of South Africa?
Provide a short and direct response. -127.89. In the year 2004, what is the difference between the Claims (% of GDP) of Gabon and Claims (% of GDP) of Tajikistan?
Offer a very short reply. -0.4. In the year 2004, what is the difference between the Claims (% of GDP) in Japan and Claims (% of GDP) in South Africa?
Offer a very short reply. 89.94. In the year 2004, what is the difference between the Claims (% of GDP) in Japan and Claims (% of GDP) in Tajikistan?
Provide a short and direct response. 217.43. In the year 2004, what is the difference between the Claims (% of GDP) of South Africa and Claims (% of GDP) of Tajikistan?
Provide a short and direct response. 127.49. In the year 2005, what is the difference between the Claims (% of GDP) in Gabon and Claims (% of GDP) in Japan?
Your answer should be very brief. -227.77. In the year 2005, what is the difference between the Claims (% of GDP) in Gabon and Claims (% of GDP) in South Africa?
Ensure brevity in your answer.  -144.05. In the year 2005, what is the difference between the Claims (% of GDP) in Gabon and Claims (% of GDP) in Tajikistan?
Ensure brevity in your answer.  -7.55. In the year 2005, what is the difference between the Claims (% of GDP) in Japan and Claims (% of GDP) in South Africa?
Offer a very short reply. 83.72. In the year 2005, what is the difference between the Claims (% of GDP) in Japan and Claims (% of GDP) in Tajikistan?
Provide a short and direct response. 220.22. In the year 2005, what is the difference between the Claims (% of GDP) of South Africa and Claims (% of GDP) of Tajikistan?
Your answer should be compact. 136.5. In the year 2006, what is the difference between the Claims (% of GDP) of Gabon and Claims (% of GDP) of Japan?
Ensure brevity in your answer.  -221.26. In the year 2006, what is the difference between the Claims (% of GDP) of Gabon and Claims (% of GDP) of South Africa?
Give a very brief answer. -162.3. In the year 2006, what is the difference between the Claims (% of GDP) in Gabon and Claims (% of GDP) in Tajikistan?
Provide a short and direct response. -7.45. In the year 2006, what is the difference between the Claims (% of GDP) of Japan and Claims (% of GDP) of South Africa?
Provide a succinct answer. 58.96. In the year 2006, what is the difference between the Claims (% of GDP) in Japan and Claims (% of GDP) in Tajikistan?
Offer a terse response. 213.81. In the year 2006, what is the difference between the Claims (% of GDP) of South Africa and Claims (% of GDP) of Tajikistan?
Offer a very short reply. 154.85. In the year 2007, what is the difference between the Claims (% of GDP) of Gabon and Claims (% of GDP) of Japan?
Ensure brevity in your answer.  -210.99. In the year 2007, what is the difference between the Claims (% of GDP) in Gabon and Claims (% of GDP) in South Africa?
Your response must be concise. -165.67. In the year 2007, what is the difference between the Claims (% of GDP) of Gabon and Claims (% of GDP) of Tajikistan?
Provide a short and direct response. -10.66. In the year 2007, what is the difference between the Claims (% of GDP) of Japan and Claims (% of GDP) of South Africa?
Offer a terse response. 45.31. In the year 2007, what is the difference between the Claims (% of GDP) of Japan and Claims (% of GDP) of Tajikistan?
Make the answer very short. 200.33. In the year 2007, what is the difference between the Claims (% of GDP) in South Africa and Claims (% of GDP) in Tajikistan?
Make the answer very short. 155.02. In the year 2008, what is the difference between the Claims (% of GDP) in Gabon and Claims (% of GDP) in Japan?
Your answer should be very brief. -206.45. In the year 2008, what is the difference between the Claims (% of GDP) in Gabon and Claims (% of GDP) in South Africa?
Provide a short and direct response. -144.15. In the year 2008, what is the difference between the Claims (% of GDP) of Gabon and Claims (% of GDP) of Tajikistan?
Keep it short and to the point. -25.13. In the year 2008, what is the difference between the Claims (% of GDP) in Japan and Claims (% of GDP) in South Africa?
Provide a short and direct response. 62.3. In the year 2008, what is the difference between the Claims (% of GDP) in Japan and Claims (% of GDP) in Tajikistan?
Offer a terse response. 181.32. In the year 2008, what is the difference between the Claims (% of GDP) in South Africa and Claims (% of GDP) in Tajikistan?
Offer a terse response. 119.02. What is the ratio of the Claims (% of GDP) of Gabon in 2002 to that in 2003?
Offer a terse response. 1.11. What is the ratio of the Claims (% of GDP) of Japan in 2002 to that in 2003?
Offer a very short reply. 1.01. What is the ratio of the Claims (% of GDP) in Tajikistan in 2002 to that in 2003?
Provide a succinct answer. 1.08. What is the ratio of the Claims (% of GDP) in Gabon in 2002 to that in 2004?
Make the answer very short. 1.44. What is the ratio of the Claims (% of GDP) in Japan in 2002 to that in 2004?
Your response must be concise. 1.04. What is the ratio of the Claims (% of GDP) in South Africa in 2002 to that in 2004?
Offer a terse response. 0.87. What is the ratio of the Claims (% of GDP) of Tajikistan in 2002 to that in 2004?
Provide a succinct answer. 1.74. What is the ratio of the Claims (% of GDP) of Gabon in 2002 to that in 2005?
Your answer should be very brief. 1.6. What is the ratio of the Claims (% of GDP) of South Africa in 2002 to that in 2005?
Provide a short and direct response. 0.79. What is the ratio of the Claims (% of GDP) in Tajikistan in 2002 to that in 2005?
Your answer should be very brief. 1.1. What is the ratio of the Claims (% of GDP) of Gabon in 2002 to that in 2006?
Your answer should be compact. 1.43. What is the ratio of the Claims (% of GDP) in Japan in 2002 to that in 2006?
Provide a succinct answer. 1.03. What is the ratio of the Claims (% of GDP) in South Africa in 2002 to that in 2006?
Your response must be concise. 0.7. What is the ratio of the Claims (% of GDP) in Tajikistan in 2002 to that in 2006?
Your answer should be very brief. 1.03. What is the ratio of the Claims (% of GDP) of Gabon in 2002 to that in 2007?
Ensure brevity in your answer.  1.37. What is the ratio of the Claims (% of GDP) in Japan in 2002 to that in 2007?
Make the answer very short. 1.07. What is the ratio of the Claims (% of GDP) of South Africa in 2002 to that in 2007?
Make the answer very short. 0.68. What is the ratio of the Claims (% of GDP) of Tajikistan in 2002 to that in 2007?
Your response must be concise. 0.86. What is the ratio of the Claims (% of GDP) of Gabon in 2002 to that in 2008?
Your answer should be very brief. 1.61. What is the ratio of the Claims (% of GDP) in Japan in 2002 to that in 2008?
Give a very brief answer. 1.1. What is the ratio of the Claims (% of GDP) of South Africa in 2002 to that in 2008?
Keep it short and to the point. 0.79. What is the ratio of the Claims (% of GDP) in Tajikistan in 2002 to that in 2008?
Keep it short and to the point. 0.53. What is the ratio of the Claims (% of GDP) in Gabon in 2003 to that in 2004?
Your answer should be compact. 1.3. What is the ratio of the Claims (% of GDP) in Japan in 2003 to that in 2004?
Keep it short and to the point. 1.04. What is the ratio of the Claims (% of GDP) in South Africa in 2003 to that in 2004?
Your answer should be very brief. 0.93. What is the ratio of the Claims (% of GDP) in Tajikistan in 2003 to that in 2004?
Provide a short and direct response. 1.61. What is the ratio of the Claims (% of GDP) in Gabon in 2003 to that in 2005?
Provide a short and direct response. 1.45. What is the ratio of the Claims (% of GDP) of Japan in 2003 to that in 2005?
Provide a short and direct response. 1. What is the ratio of the Claims (% of GDP) of South Africa in 2003 to that in 2005?
Give a very brief answer. 0.84. What is the ratio of the Claims (% of GDP) in Tajikistan in 2003 to that in 2005?
Offer a very short reply. 1.02. What is the ratio of the Claims (% of GDP) in Gabon in 2003 to that in 2006?
Make the answer very short. 1.29. What is the ratio of the Claims (% of GDP) of Japan in 2003 to that in 2006?
Provide a succinct answer. 1.02. What is the ratio of the Claims (% of GDP) in South Africa in 2003 to that in 2006?
Your response must be concise. 0.74. What is the ratio of the Claims (% of GDP) in Tajikistan in 2003 to that in 2006?
Provide a short and direct response. 0.96. What is the ratio of the Claims (% of GDP) in Gabon in 2003 to that in 2007?
Give a very brief answer. 1.24. What is the ratio of the Claims (% of GDP) of Japan in 2003 to that in 2007?
Your answer should be compact. 1.07. What is the ratio of the Claims (% of GDP) in South Africa in 2003 to that in 2007?
Your response must be concise. 0.73. What is the ratio of the Claims (% of GDP) of Tajikistan in 2003 to that in 2007?
Offer a terse response. 0.79. What is the ratio of the Claims (% of GDP) in Gabon in 2003 to that in 2008?
Provide a succinct answer. 1.45. What is the ratio of the Claims (% of GDP) in Japan in 2003 to that in 2008?
Provide a succinct answer. 1.1. What is the ratio of the Claims (% of GDP) in South Africa in 2003 to that in 2008?
Offer a terse response. 0.84. What is the ratio of the Claims (% of GDP) in Tajikistan in 2003 to that in 2008?
Ensure brevity in your answer.  0.49. What is the ratio of the Claims (% of GDP) in Gabon in 2004 to that in 2005?
Offer a very short reply. 1.12. What is the ratio of the Claims (% of GDP) of Japan in 2004 to that in 2005?
Offer a very short reply. 0.96. What is the ratio of the Claims (% of GDP) in South Africa in 2004 to that in 2005?
Your answer should be very brief. 0.9. What is the ratio of the Claims (% of GDP) in Tajikistan in 2004 to that in 2005?
Give a very brief answer. 0.63. What is the ratio of the Claims (% of GDP) of Japan in 2004 to that in 2006?
Give a very brief answer. 0.98. What is the ratio of the Claims (% of GDP) of South Africa in 2004 to that in 2006?
Give a very brief answer. 0.8. What is the ratio of the Claims (% of GDP) of Tajikistan in 2004 to that in 2006?
Make the answer very short. 0.59. What is the ratio of the Claims (% of GDP) of Gabon in 2004 to that in 2007?
Your response must be concise. 0.95. What is the ratio of the Claims (% of GDP) in Japan in 2004 to that in 2007?
Offer a very short reply. 1.03. What is the ratio of the Claims (% of GDP) in South Africa in 2004 to that in 2007?
Provide a succinct answer. 0.78. What is the ratio of the Claims (% of GDP) of Tajikistan in 2004 to that in 2007?
Offer a terse response. 0.49. What is the ratio of the Claims (% of GDP) in Gabon in 2004 to that in 2008?
Ensure brevity in your answer.  1.12. What is the ratio of the Claims (% of GDP) in Japan in 2004 to that in 2008?
Provide a short and direct response. 1.06. What is the ratio of the Claims (% of GDP) of South Africa in 2004 to that in 2008?
Your answer should be compact. 0.9. What is the ratio of the Claims (% of GDP) in Tajikistan in 2004 to that in 2008?
Offer a terse response. 0.31. What is the ratio of the Claims (% of GDP) in Gabon in 2005 to that in 2006?
Offer a terse response. 0.89. What is the ratio of the Claims (% of GDP) of Japan in 2005 to that in 2006?
Your response must be concise. 1.02. What is the ratio of the Claims (% of GDP) of South Africa in 2005 to that in 2006?
Your answer should be compact. 0.89. What is the ratio of the Claims (% of GDP) of Tajikistan in 2005 to that in 2006?
Make the answer very short. 0.94. What is the ratio of the Claims (% of GDP) of Gabon in 2005 to that in 2007?
Your answer should be compact. 0.85. What is the ratio of the Claims (% of GDP) in Japan in 2005 to that in 2007?
Your response must be concise. 1.07. What is the ratio of the Claims (% of GDP) in South Africa in 2005 to that in 2007?
Provide a short and direct response. 0.87. What is the ratio of the Claims (% of GDP) in Tajikistan in 2005 to that in 2007?
Give a very brief answer. 0.78. What is the ratio of the Claims (% of GDP) in Japan in 2005 to that in 2008?
Your response must be concise. 1.1. What is the ratio of the Claims (% of GDP) of Tajikistan in 2005 to that in 2008?
Ensure brevity in your answer.  0.49. What is the ratio of the Claims (% of GDP) of Gabon in 2006 to that in 2007?
Ensure brevity in your answer.  0.96. What is the ratio of the Claims (% of GDP) of Japan in 2006 to that in 2007?
Ensure brevity in your answer.  1.04. What is the ratio of the Claims (% of GDP) of South Africa in 2006 to that in 2007?
Give a very brief answer. 0.98. What is the ratio of the Claims (% of GDP) in Tajikistan in 2006 to that in 2007?
Offer a terse response. 0.83. What is the ratio of the Claims (% of GDP) in Gabon in 2006 to that in 2008?
Keep it short and to the point. 1.13. What is the ratio of the Claims (% of GDP) in Japan in 2006 to that in 2008?
Provide a succinct answer. 1.07. What is the ratio of the Claims (% of GDP) of South Africa in 2006 to that in 2008?
Your answer should be very brief. 1.13. What is the ratio of the Claims (% of GDP) of Tajikistan in 2006 to that in 2008?
Your response must be concise. 0.52. What is the ratio of the Claims (% of GDP) in Gabon in 2007 to that in 2008?
Provide a succinct answer. 1.18. What is the ratio of the Claims (% of GDP) of Japan in 2007 to that in 2008?
Provide a short and direct response. 1.03. What is the ratio of the Claims (% of GDP) in South Africa in 2007 to that in 2008?
Your answer should be compact. 1.15. What is the ratio of the Claims (% of GDP) of Tajikistan in 2007 to that in 2008?
Your response must be concise. 0.62. What is the difference between the highest and the second highest Claims (% of GDP) in Gabon?
Your answer should be compact. 1.42. What is the difference between the highest and the second highest Claims (% of GDP) in Japan?
Ensure brevity in your answer.  1.09. What is the difference between the highest and the second highest Claims (% of GDP) in South Africa?
Make the answer very short. 3.8. What is the difference between the highest and the second highest Claims (% of GDP) in Tajikistan?
Keep it short and to the point. 12.9. What is the difference between the highest and the lowest Claims (% of GDP) in Gabon?
Your answer should be very brief. 5.48. What is the difference between the highest and the lowest Claims (% of GDP) of Japan?
Provide a succinct answer. 22.45. What is the difference between the highest and the lowest Claims (% of GDP) in South Africa?
Keep it short and to the point. 55.57. What is the difference between the highest and the lowest Claims (% of GDP) of Tajikistan?
Your response must be concise. 23.65. 